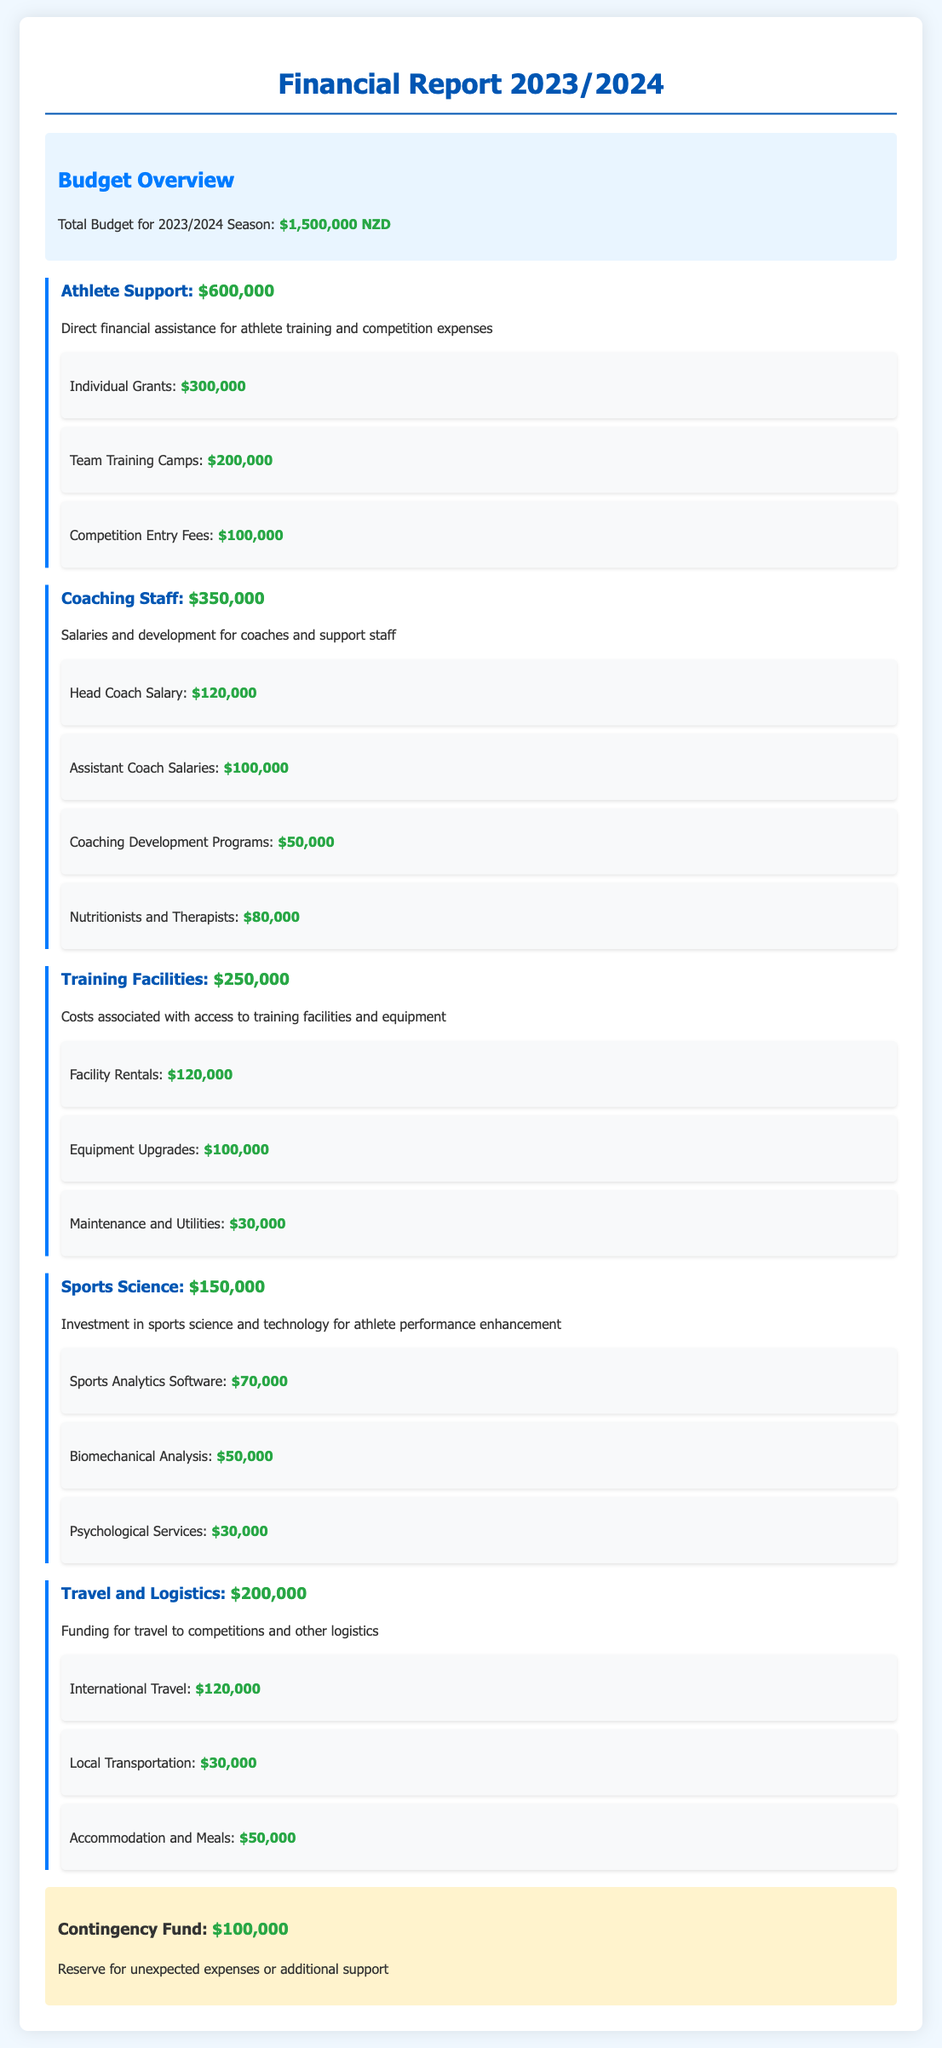What is the total budget for the 2023/2024 season? The total budget is stated clearly at the beginning of the report.
Answer: $1,500,000 NZD How much is allocated for Athlete Support? The report details the allocation for Athlete Support under its own section.
Answer: $600,000 What percentage of the total budget is dedicated to Coaching Staff? The percentage can be calculated by dividing the Coaching Staff budget by the total budget and multiplying by 100.
Answer: 23.3% What is the amount set aside for Sports Science? The document specifies the exact figure dedicated to Sports Science.
Answer: $150,000 What are the total costs for Training Facilities? The report provides a specific amount related to Training Facilities.
Answer: $250,000 How much is allocated for Individual Grants? Individual Grants are itemized under Athlete Support with a specific amount.
Answer: $300,000 If the total budget is $1,500,000, what is the remaining budget after subtracting the totals for Athlete Support and Coaching Staff? The remaining budget can be derived by subtracting the combined totals of Athlete Support and Coaching Staff from the total budget.
Answer: $550,000 What is included in the Travel and Logistics budget? The Travel and Logistics section breaks down costs into specific categories mentioned in the report.
Answer: International Travel, Local Transportation, Accommodation and Meals What is the amount set aside for the Contingency Fund? The Contingency Fund is clearly mentioned in the report with an allocated amount.
Answer: $100,000 What is the total amount for Team Training Camps? The Team Training Camps budget is specified under Athlete Support.
Answer: $200,000 